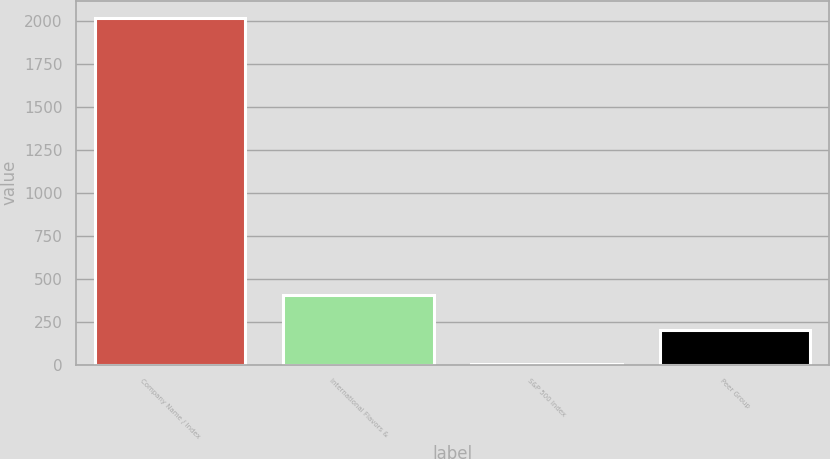Convert chart to OTSL. <chart><loc_0><loc_0><loc_500><loc_500><bar_chart><fcel>Company Name / Index<fcel>International Flavors &<fcel>S&P 500 Index<fcel>Peer Group<nl><fcel>2015<fcel>404.1<fcel>1.38<fcel>202.74<nl></chart> 